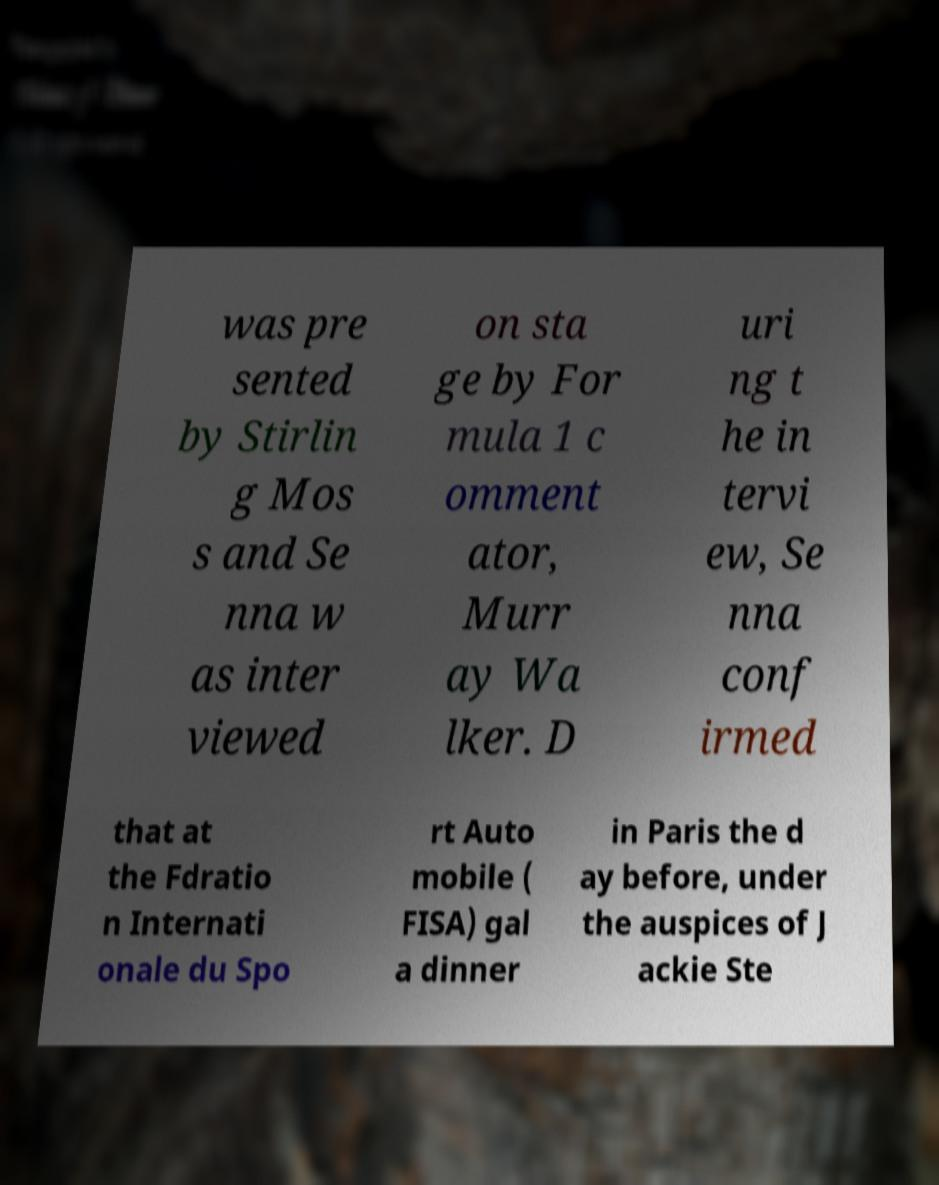Can you accurately transcribe the text from the provided image for me? was pre sented by Stirlin g Mos s and Se nna w as inter viewed on sta ge by For mula 1 c omment ator, Murr ay Wa lker. D uri ng t he in tervi ew, Se nna conf irmed that at the Fdratio n Internati onale du Spo rt Auto mobile ( FISA) gal a dinner in Paris the d ay before, under the auspices of J ackie Ste 